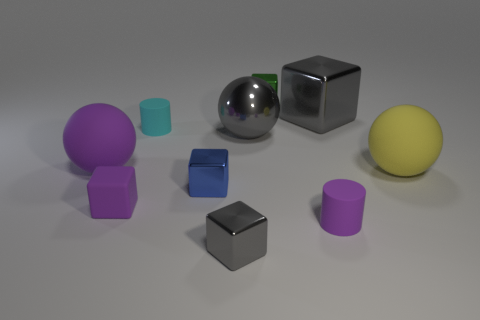Subtract all green cubes. How many cubes are left? 4 Subtract all tiny matte blocks. How many blocks are left? 4 Subtract all yellow cubes. Subtract all yellow cylinders. How many cubes are left? 5 Subtract all cylinders. How many objects are left? 8 Add 1 purple metal cubes. How many purple metal cubes exist? 1 Subtract 1 blue cubes. How many objects are left? 9 Subtract all tiny gray objects. Subtract all blue cubes. How many objects are left? 8 Add 1 big yellow rubber objects. How many big yellow rubber objects are left? 2 